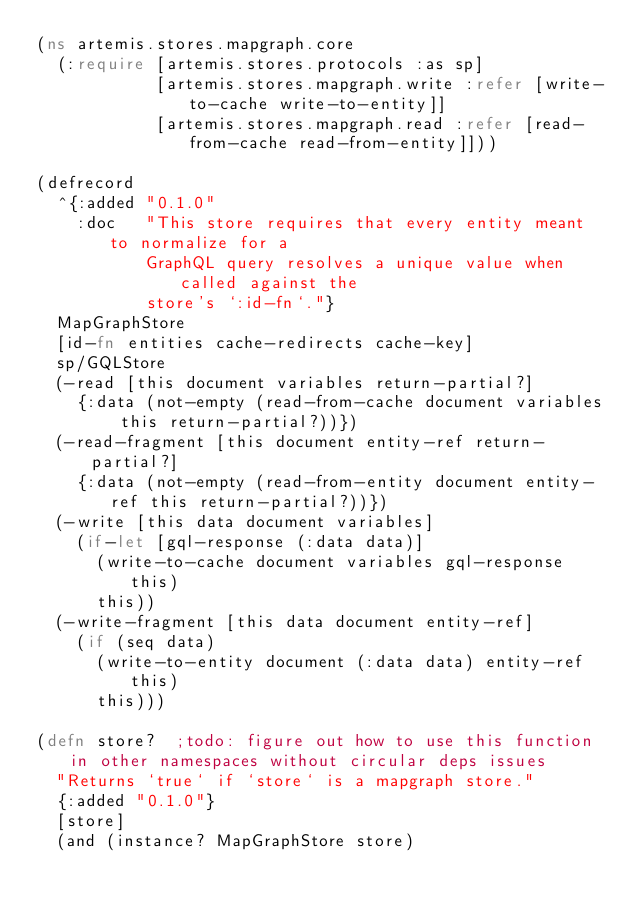<code> <loc_0><loc_0><loc_500><loc_500><_Clojure_>(ns artemis.stores.mapgraph.core
  (:require [artemis.stores.protocols :as sp]
            [artemis.stores.mapgraph.write :refer [write-to-cache write-to-entity]]
            [artemis.stores.mapgraph.read :refer [read-from-cache read-from-entity]]))

(defrecord
  ^{:added "0.1.0"
    :doc   "This store requires that every entity meant to normalize for a
           GraphQL query resolves a unique value when called against the
           store's `:id-fn`."}
  MapGraphStore
  [id-fn entities cache-redirects cache-key]
  sp/GQLStore
  (-read [this document variables return-partial?]
    {:data (not-empty (read-from-cache document variables this return-partial?))})
  (-read-fragment [this document entity-ref return-partial?]
    {:data (not-empty (read-from-entity document entity-ref this return-partial?))})
  (-write [this data document variables]
    (if-let [gql-response (:data data)]
      (write-to-cache document variables gql-response this)
      this))
  (-write-fragment [this data document entity-ref]
    (if (seq data)
      (write-to-entity document (:data data) entity-ref this)
      this)))

(defn store?  ;todo: figure out how to use this function in other namespaces without circular deps issues
  "Returns `true` if `store` is a mapgraph store."
  {:added "0.1.0"}
  [store]
  (and (instance? MapGraphStore store)</code> 